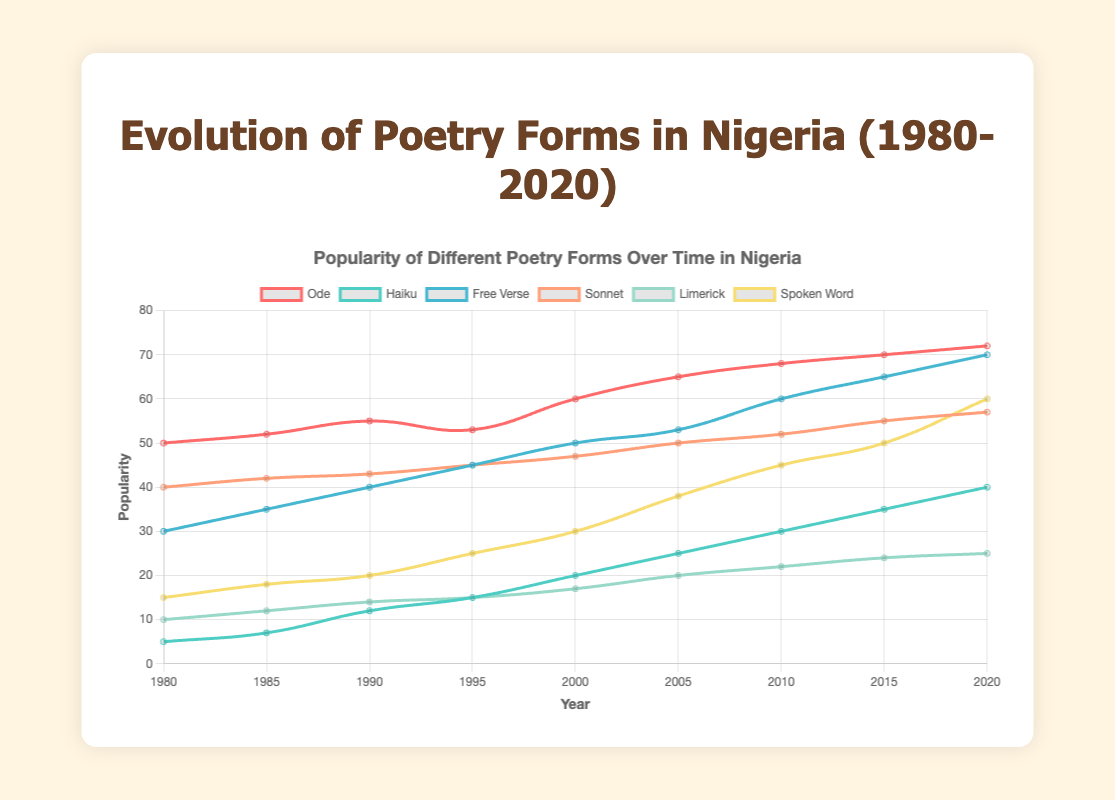How has the popularity of Spoken Word poetry changed from 1980 to 2020? To determine this, look at the data points for Spoken Word poetry form in the figure for 1980 and 2020. In 1980, the value is 15 and in 2020, it's 60. This shows an increase of 45 over the 40-year span.
Answer: Increased by 45 Which poetry form had the highest popularity in 2020? Compare the values for each poetry form in the year 2020. Ode has 72, Haiku has 40, Free Verse has 70, Sonnet has 57, Limerick has 25, Spoken Word has 60. Ode, which has the value of 72, is the highest.
Answer: Ode In which year did Free Verse surpass 50 in popularity? Look at the data points for Free Verse and find the first year where the value exceeds 50. It surpasses 50 in the year 2000 where the value reached 53.
Answer: 2000 What is the difference in popularity between Ode and Limerick in 2020? Find the values for Ode and Limerick for the year 2020. Ode is 72 and Limerick is 25. The difference between them is 72 - 25 = 47.
Answer: 47 Which poetry form has consistently increased in popularity every 5 years without any decrease over the observed period? Examine each poetry form’s values from 1980 to 2020. Ode (50, 52, 55, 53, 60, 65, 68, 70, 72) has a dip, so it's excluded. Haiku (5, 7, 12, 15, 20, 25, 30, 35, 40) consistently increases. Free Verse (30, 35, 40, 45, 50, 53, 60, 65, 70), Sonnet (40, 42, 43, 45, 47, 50, 52, 55, 57), Limerick (10, 12, 14, 15, 17, 20, 22, 24, 25), and Spoken Word (15, 18, 20, 25, 30, 38, 45, 50, 60) all increase consistently as well.
Answer: Haiku, Free Verse, Sonnet, Limerick, Spoken Word When and by how much did the popularity of Sonnet surpass 50? Find the first year where Sonnet’s value exceeds 50. It surpassed 50 in 2005 with a value of 50.5 (50 + 0.5). The increase is just 0.5 above 50 making it the significant moment.
Answer: 2005, by 0.5 Which poetry form saw the largest increase in popularity between 1995 and 2000? Calculate the difference in popularity for each poetry form between 1995 and 2000. Ode: 60 - 53 = 7, Haiku: 20 - 15 = 5, Free Verse: 50 - 45 = 5, Sonnet: 47 - 45 = 2, Limerick: 17 - 15 = 2, Spoken Word: 30 - 25 = 5. Ode had the largest increase of 7 during this period.
Answer: Ode, 7 How does the popularity trend of Haiku compare with that of Spoken Word from 2000 to 2020? Draw a comparison from the notice of values of Haiku (20, 25, 30, 35, 40) and Spoken Word (30, 38, 45, 50, 60) in the indicated years. Both trends show a consistent increase, but Spoken Word has a steeper rise in values.
Answer: Similar increase, but Spoken Word increases more steeply 